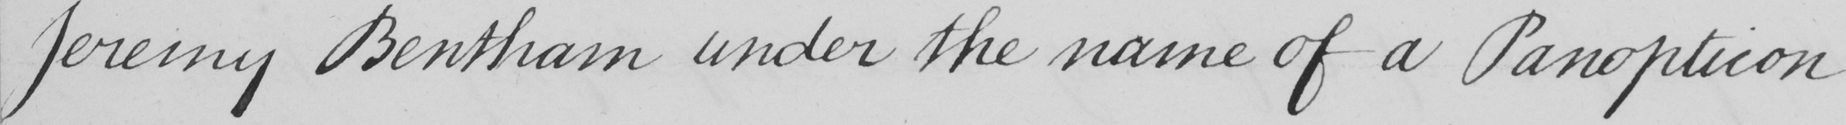What does this handwritten line say? Jeremy Bentham under the name of a Panopticon 